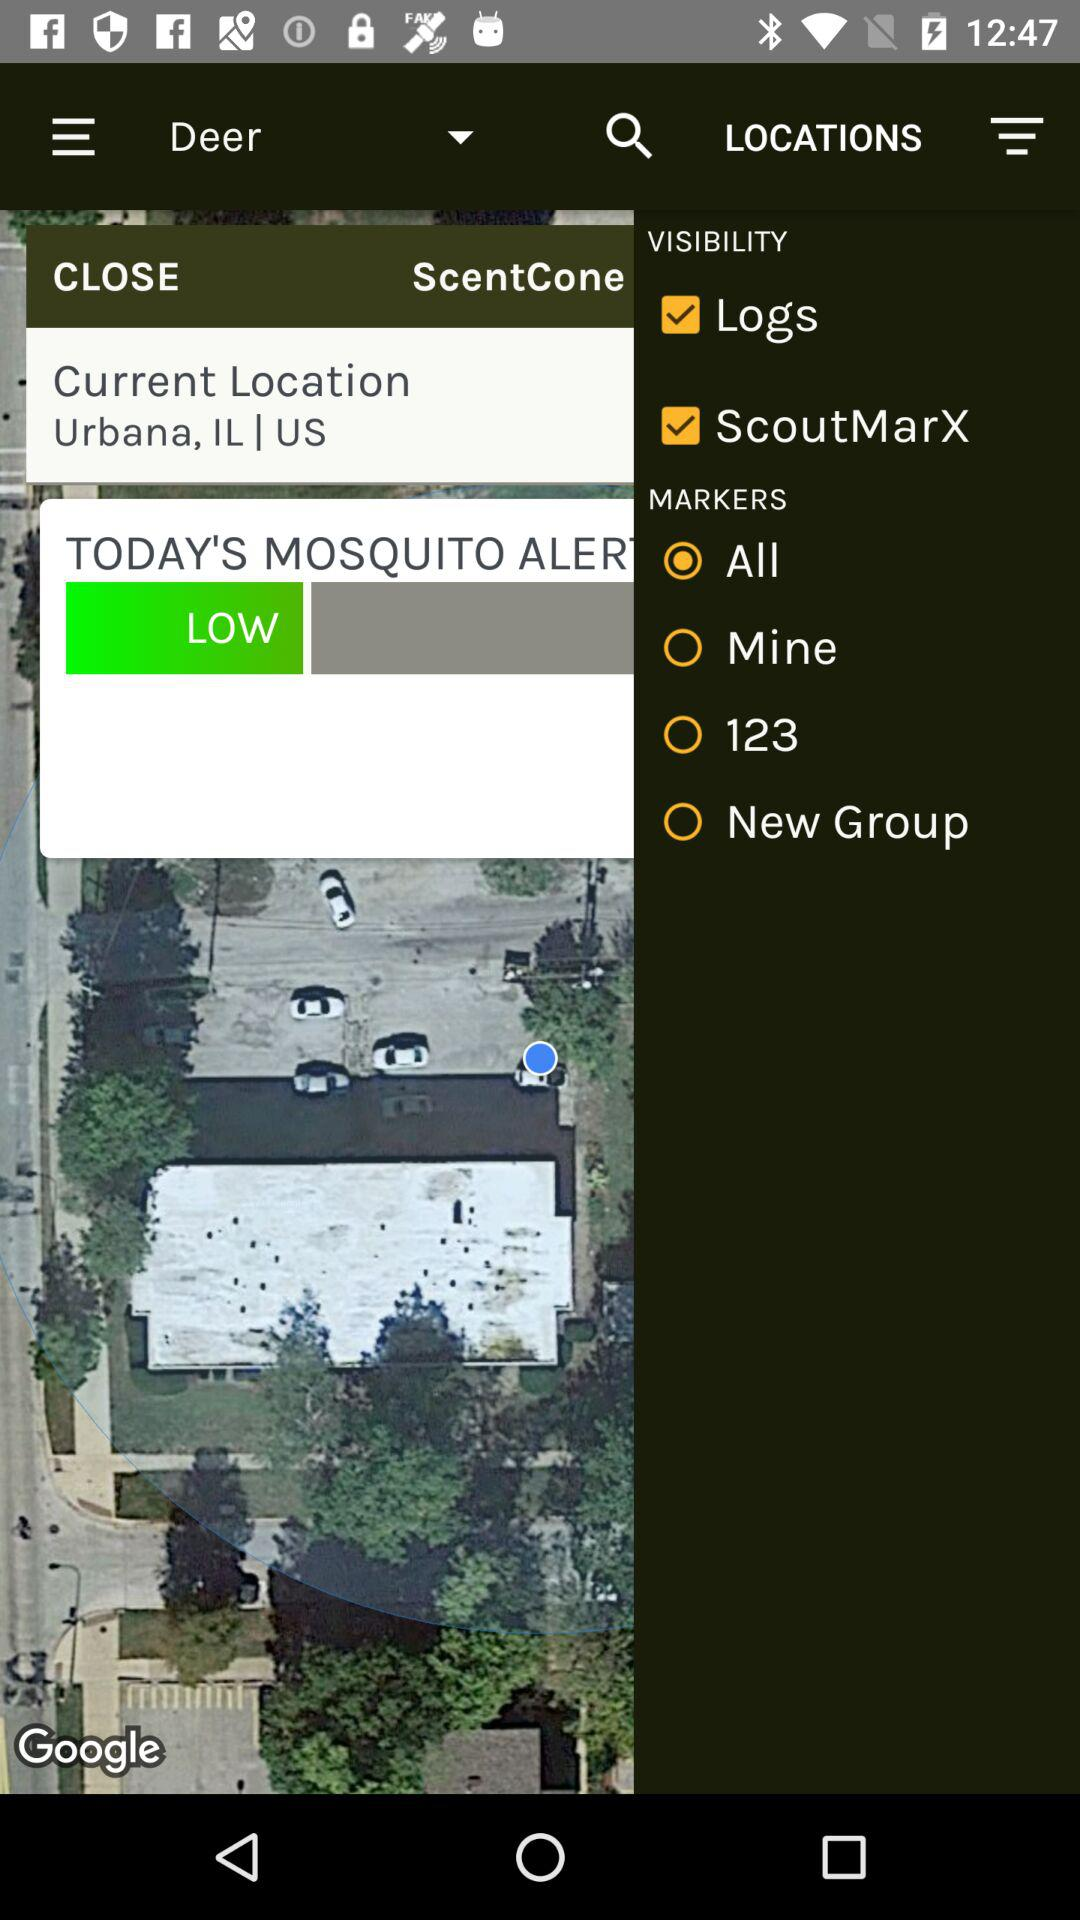Which animal is selected? The selected animal is a deer. 